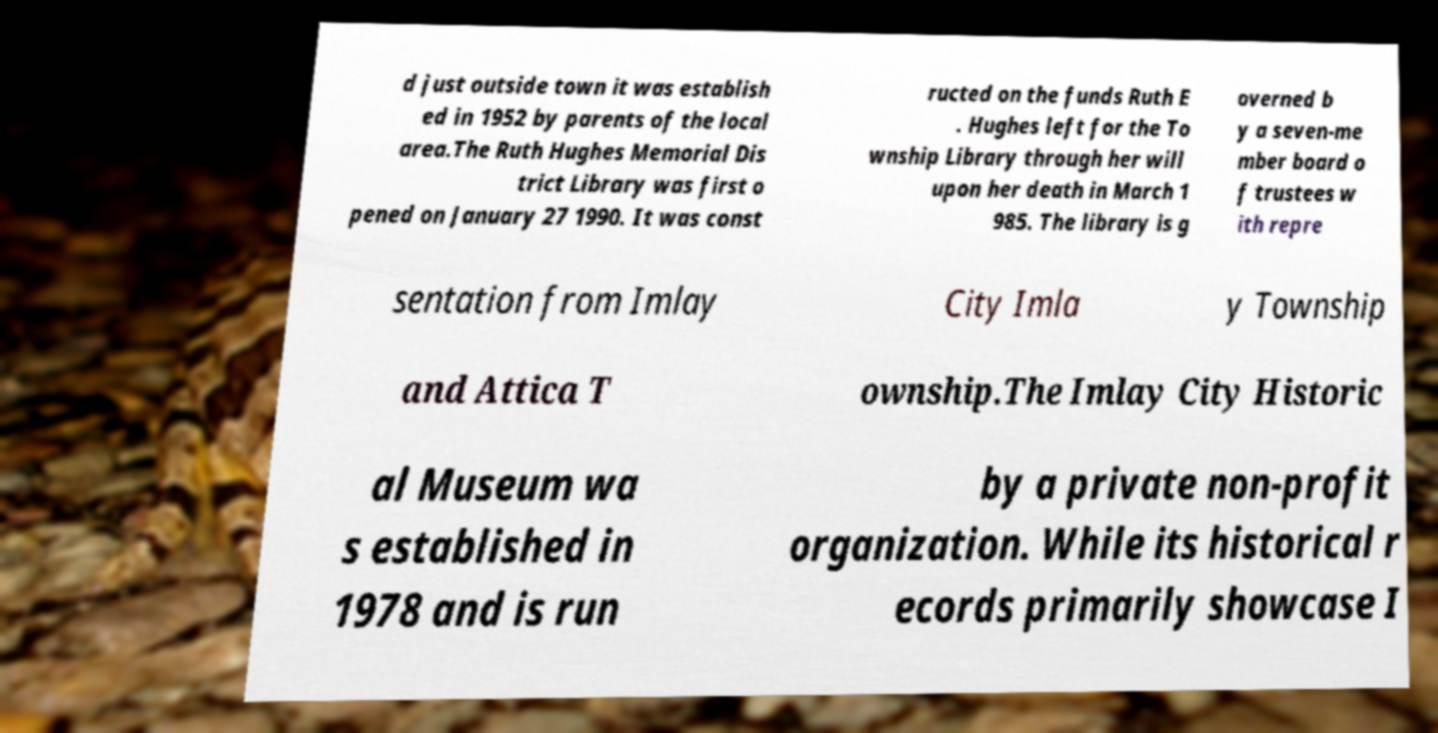Could you extract and type out the text from this image? d just outside town it was establish ed in 1952 by parents of the local area.The Ruth Hughes Memorial Dis trict Library was first o pened on January 27 1990. It was const ructed on the funds Ruth E . Hughes left for the To wnship Library through her will upon her death in March 1 985. The library is g overned b y a seven-me mber board o f trustees w ith repre sentation from Imlay City Imla y Township and Attica T ownship.The Imlay City Historic al Museum wa s established in 1978 and is run by a private non-profit organization. While its historical r ecords primarily showcase I 